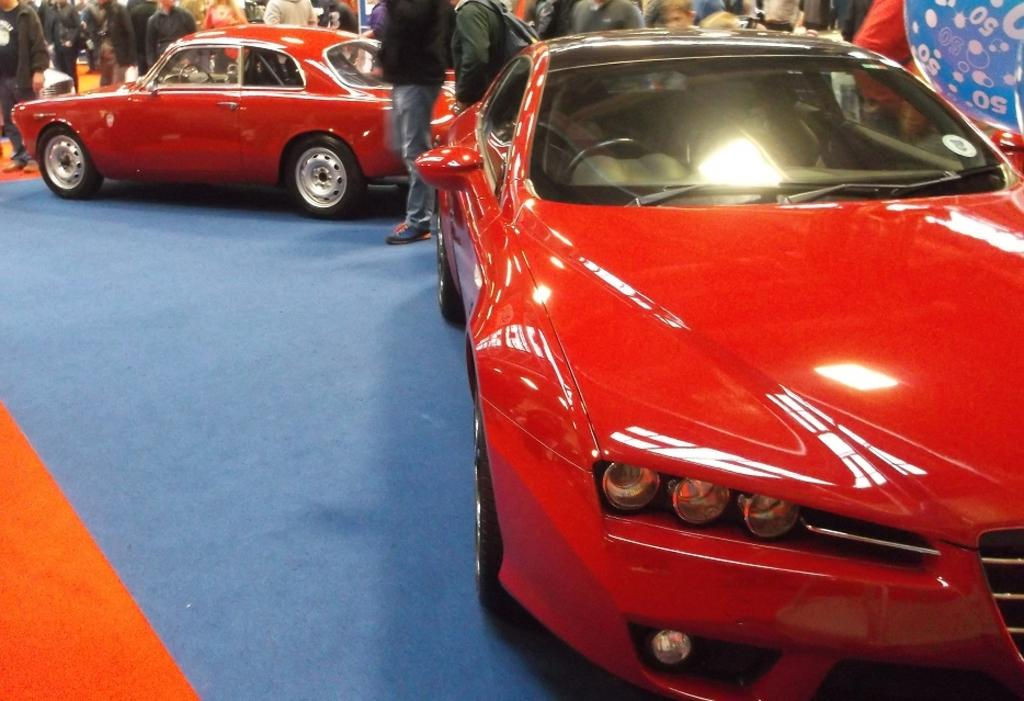What is the color of the car in the foreground of the picture? The car in the foreground of the picture is red. What is located next to the red car in the foreground? There is a blue color mat in the foreground of the picture. What can be seen in the background of the picture? There are people, at least one other car, and other objects in the background of the picture. What type of organization is depicted on the baseball in the picture? There is no baseball present in the picture; it features a red car and a blue mat in the foreground, with people, another car, and other objects in the background. 